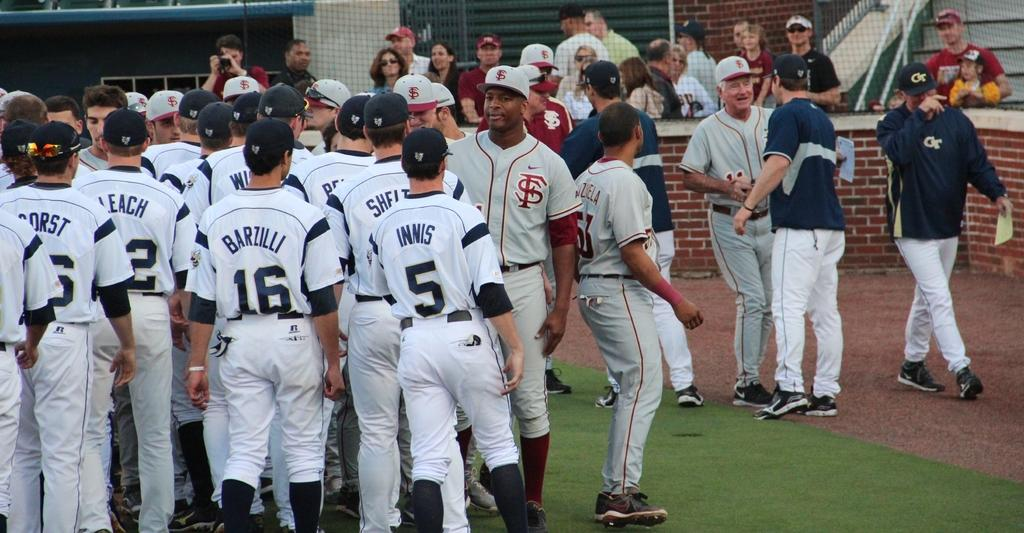<image>
Provide a brief description of the given image. Barzilli is amongst his fellow teammates at the ball field 